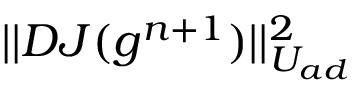<formula> <loc_0><loc_0><loc_500><loc_500>| | D J ( g ^ { n + 1 } ) | | _ { U _ { a d } } ^ { 2 }</formula> 